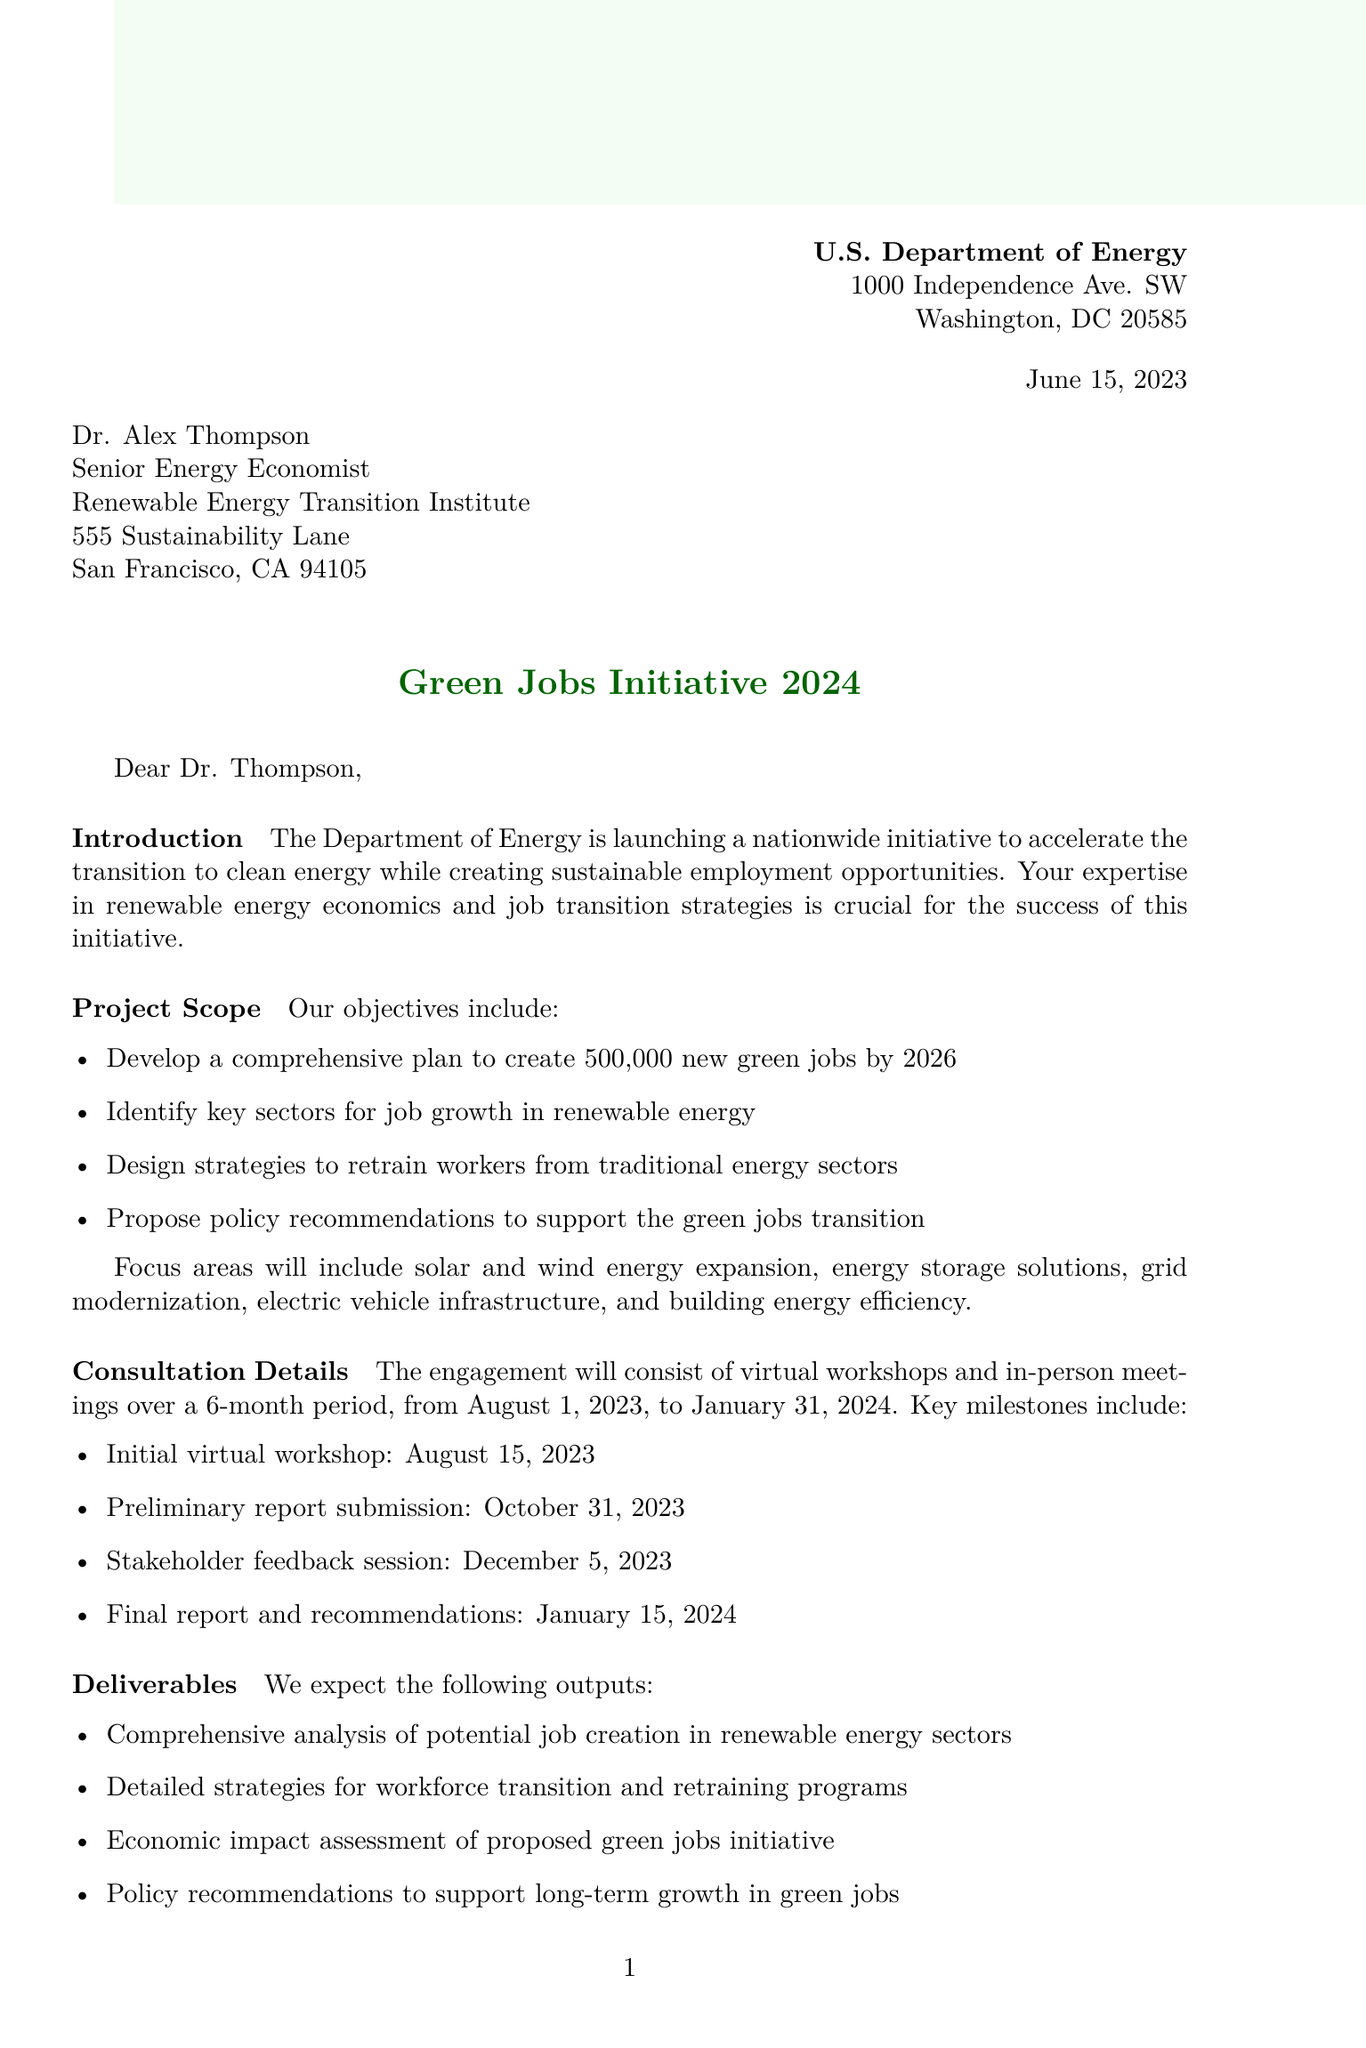what is the project title? The project title is mentioned in the header of the document as the main focus of the letter.
Answer: Green Jobs Initiative 2024 who is the recipient of the letter? The recipient's name is provided at the beginning of the letter.
Answer: Dr. Alex Thompson what is the consultation fee offered? The consultation fee is explicitly stated in the compensation section of the letter.
Answer: $25,000 when does the consultation period start? The start date of the consultation period is mentioned in the consultation details section.
Answer: August 1, 2023 how many new green jobs is the initiative aiming to create? This figure is part of the objectives outlined in the project scope section.
Answer: 500,000 what are the key sectors for job growth specified in the project? The document lists these sectors as part of the project's objectives.
Answer: renewable energy who is the DOE project lead? The name of the project lead is listed in the project team section of the letter.
Answer: Dr. Sarah Martinez what is the duration of the consultation? The duration is specified in the consultation details section of the letter.
Answer: 6 months what is the final report submission date? The exact date for the submission of the final report is stated in the consultation details.
Answer: January 15, 2024 